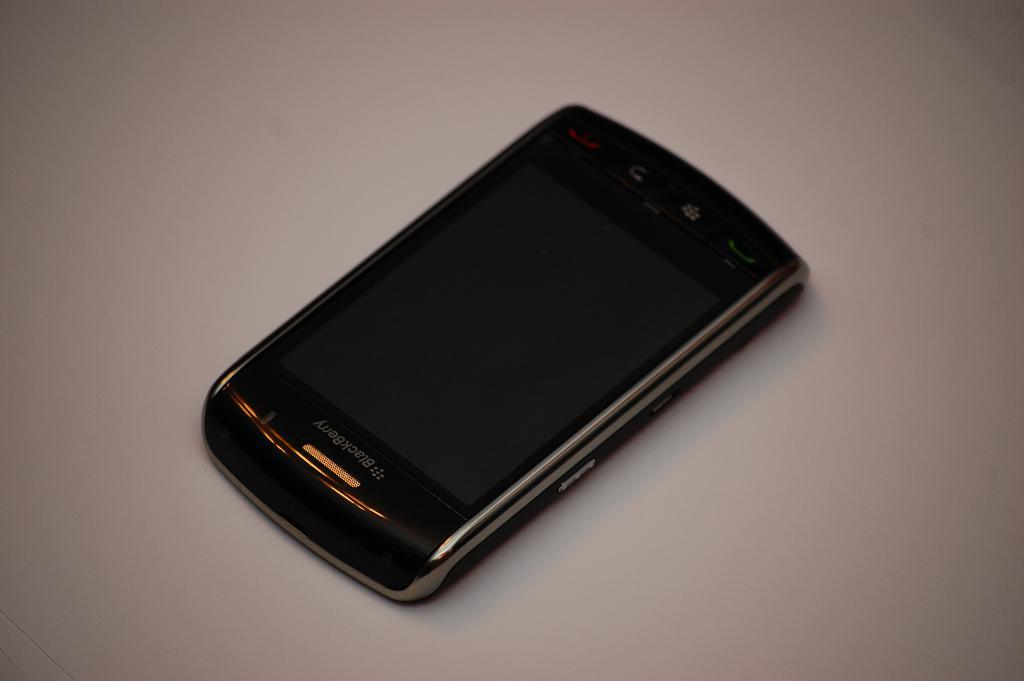<image>
Render a clear and concise summary of the photo. A black blackberry cell phone laying on the display 